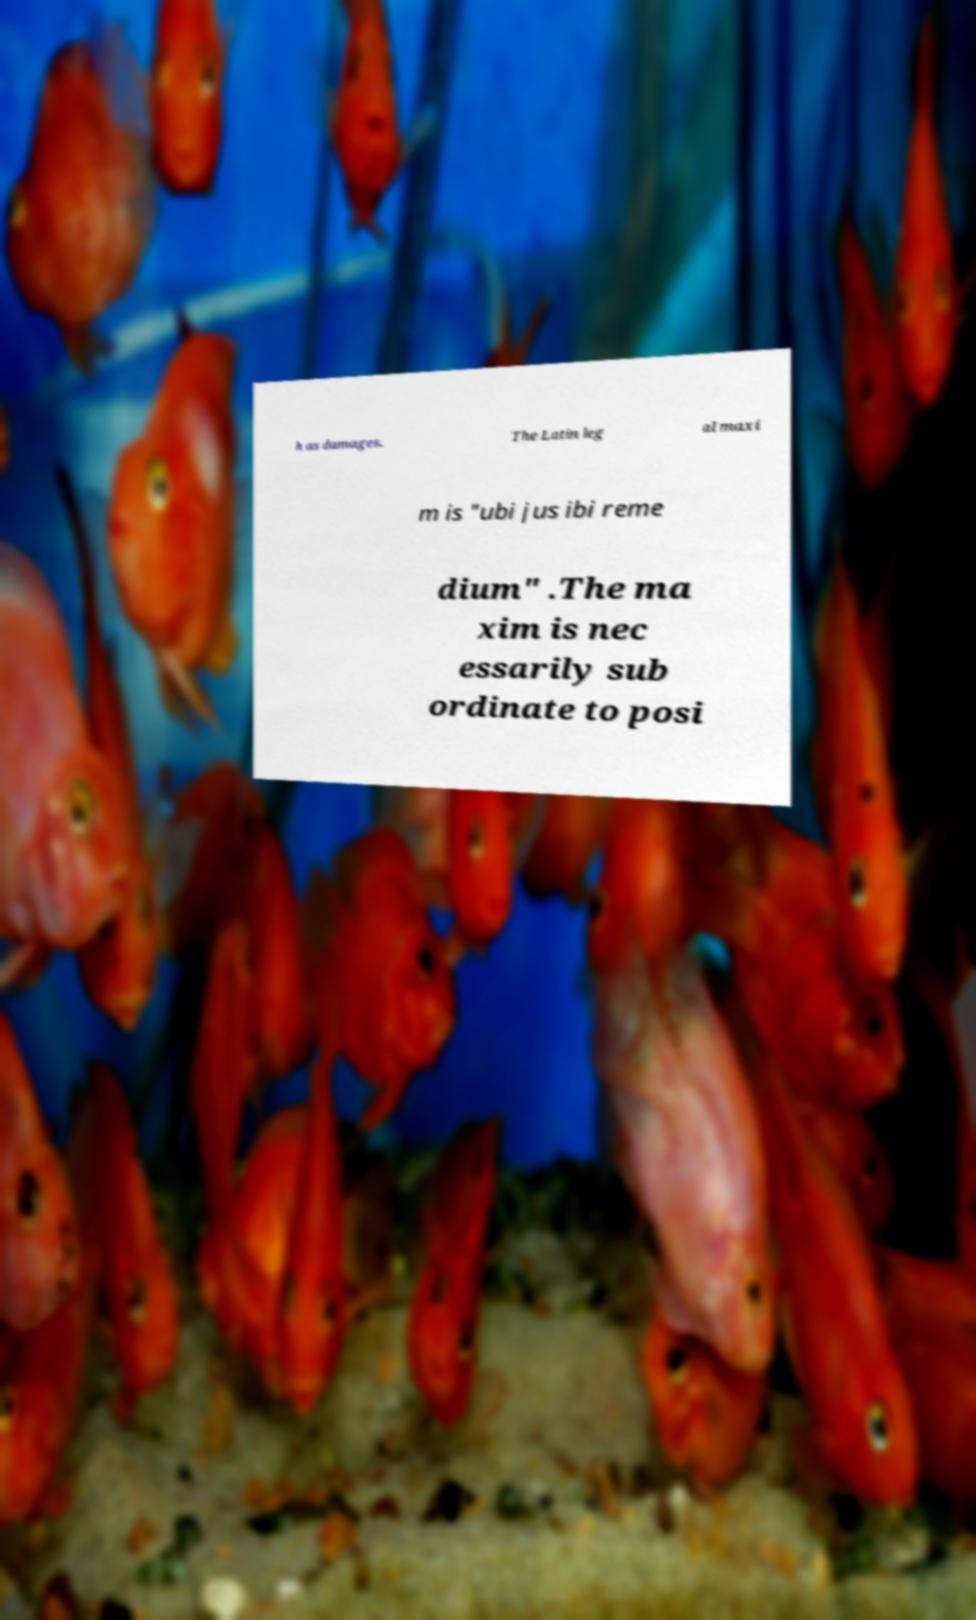Could you assist in decoding the text presented in this image and type it out clearly? h as damages. The Latin leg al maxi m is "ubi jus ibi reme dium" .The ma xim is nec essarily sub ordinate to posi 